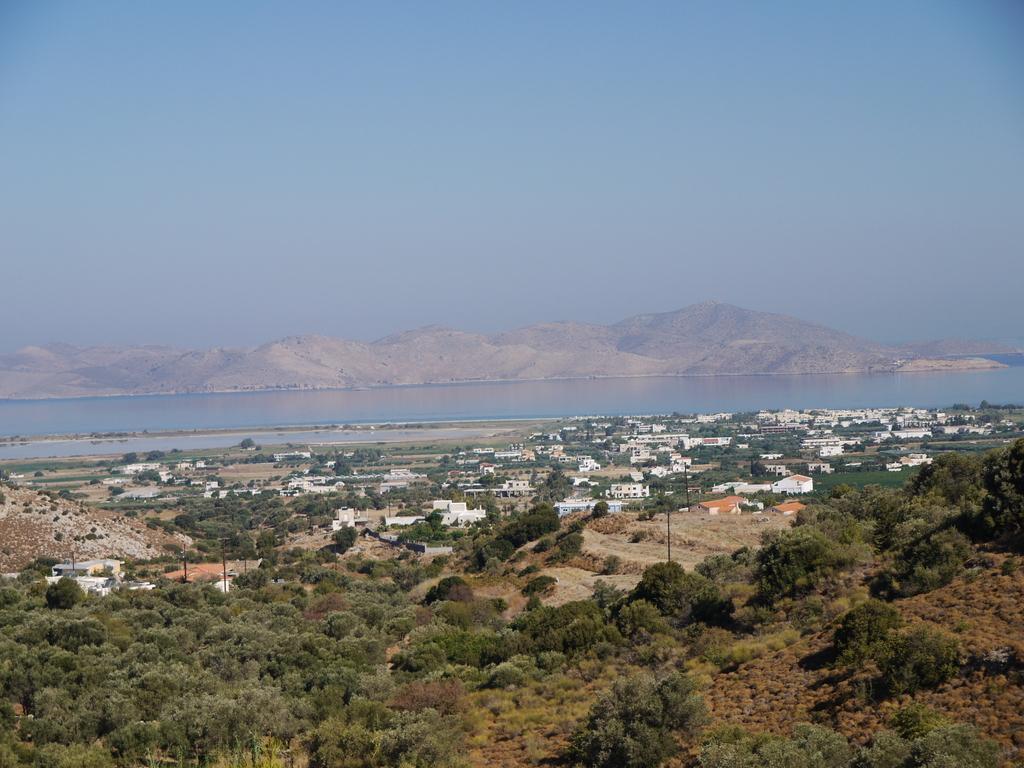How would you summarize this image in a sentence or two? In this picture we can see trees, houses, water, hills and a sky. 